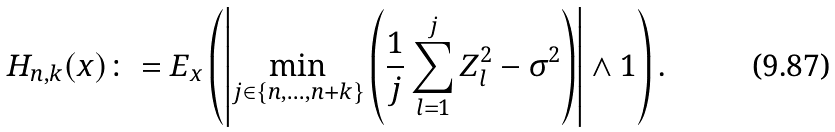Convert formula to latex. <formula><loc_0><loc_0><loc_500><loc_500>H _ { n , k } ( x ) \colon = E _ { x } \left ( \left | \min _ { j \in \{ n , \dots , n + k \} } \left ( \frac { 1 } { j } \sum _ { l = 1 } ^ { j } Z _ { l } ^ { 2 } - \sigma ^ { 2 } \right ) \right | \wedge 1 \right ) .</formula> 